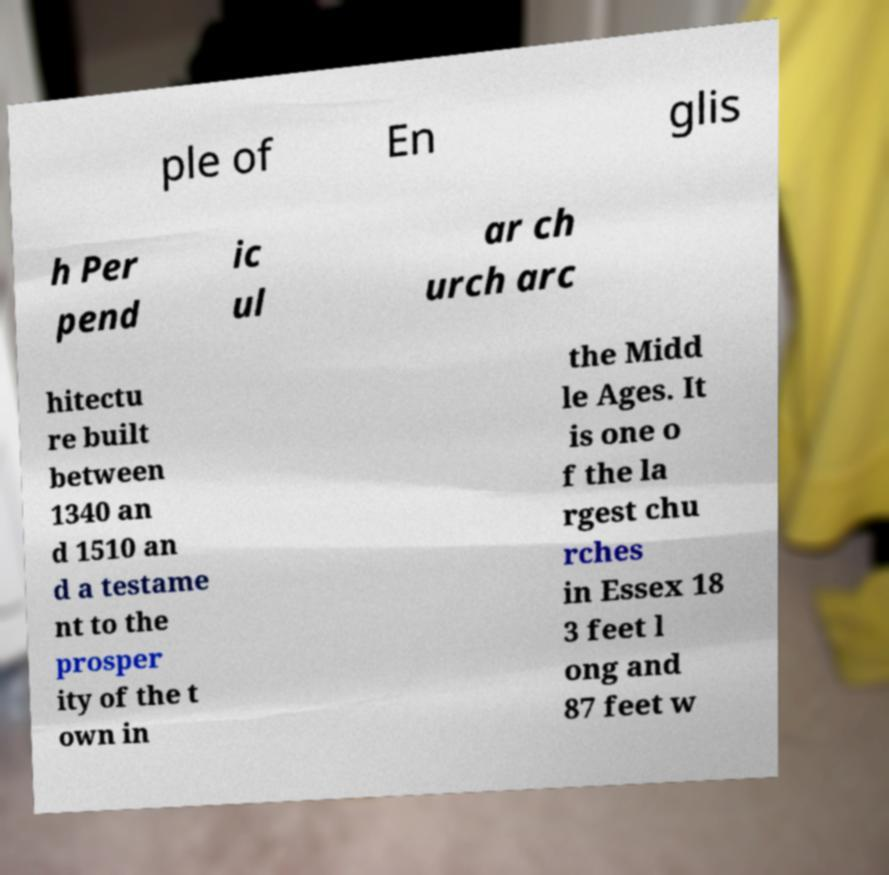There's text embedded in this image that I need extracted. Can you transcribe it verbatim? ple of En glis h Per pend ic ul ar ch urch arc hitectu re built between 1340 an d 1510 an d a testame nt to the prosper ity of the t own in the Midd le Ages. It is one o f the la rgest chu rches in Essex 18 3 feet l ong and 87 feet w 